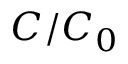<formula> <loc_0><loc_0><loc_500><loc_500>C / C _ { 0 }</formula> 